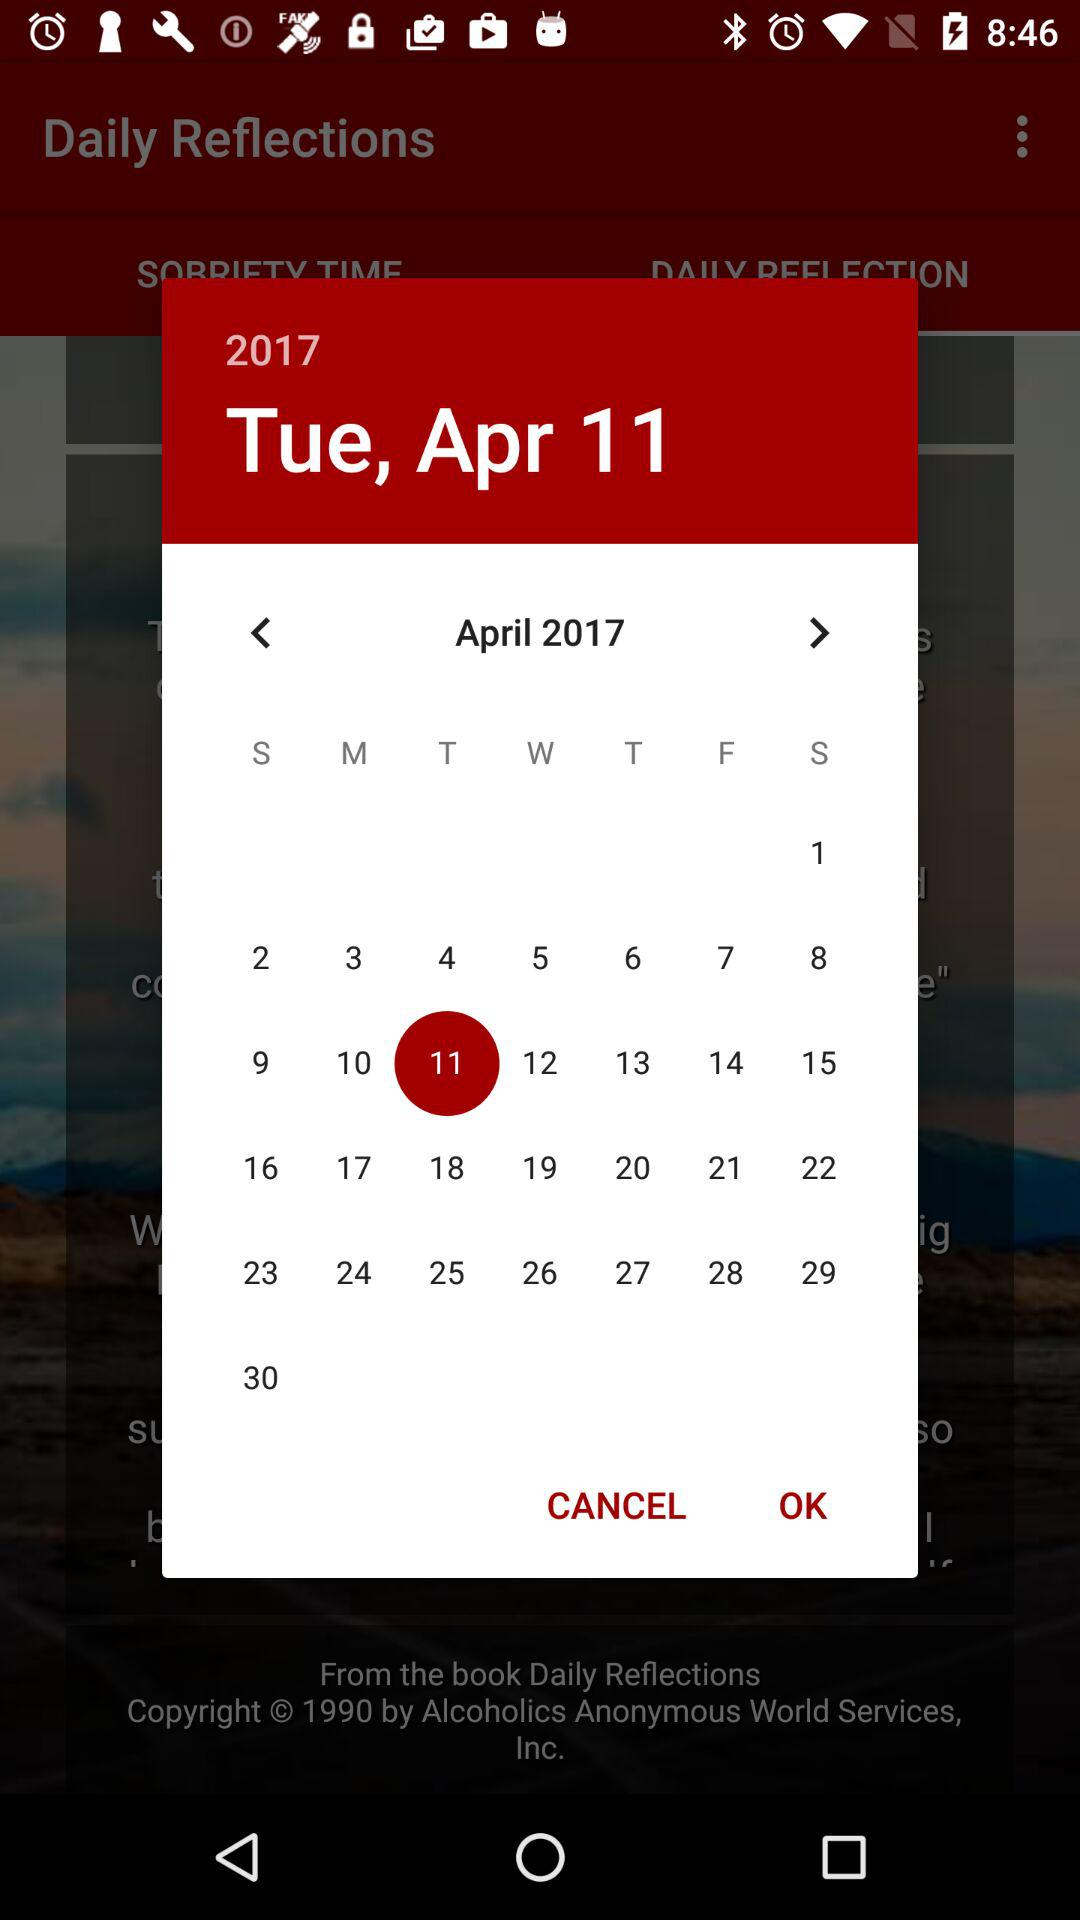What day falls on April 11, 2017? The day is Tuesday. 